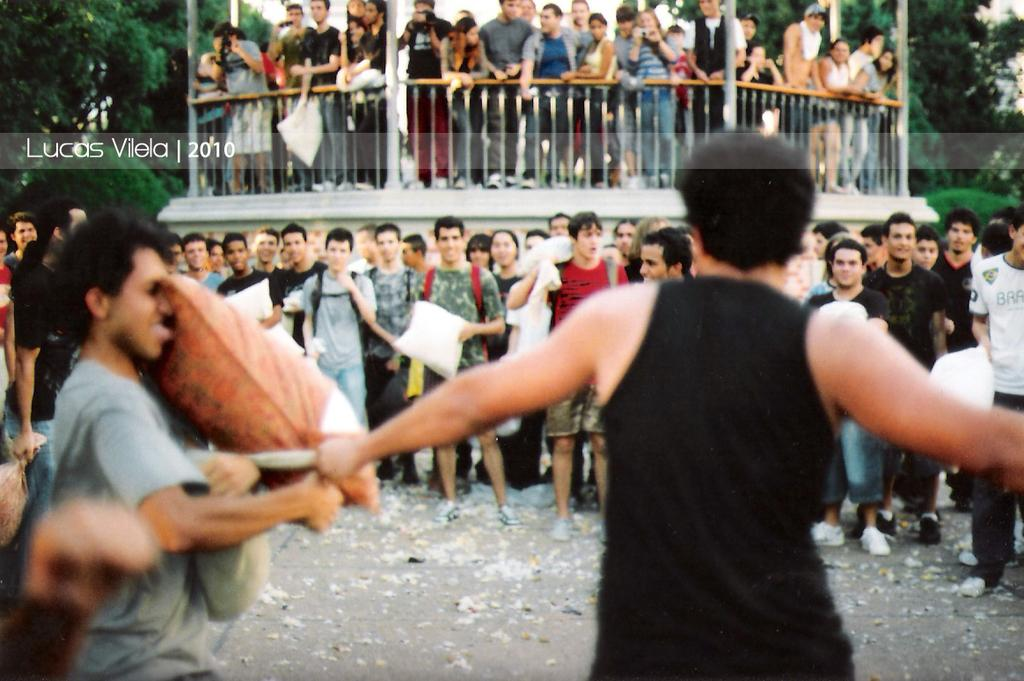How many people are in the image? There is a group of people in the image, but the exact number is not specified. Can you describe the arrangement of the people in the image? The people are scattered throughout the image. What is the purpose of the fence in the image? The purpose of the fence is not specified in the facts provided. What type of structure is depicted in the image? There is a building in the image. What can be seen in the background of the image? There are trees in the background of the image. How does the pump help the people breathe in the image? There is no pump present in the image, and therefore no such assistance can be observed. 